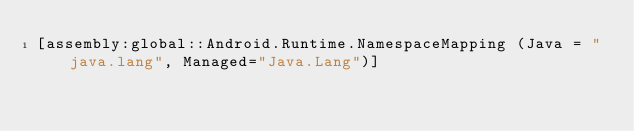Convert code to text. <code><loc_0><loc_0><loc_500><loc_500><_C#_>[assembly:global::Android.Runtime.NamespaceMapping (Java = "java.lang", Managed="Java.Lang")]</code> 